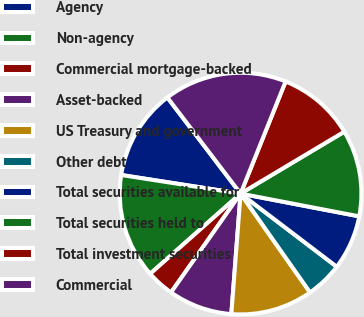<chart> <loc_0><loc_0><loc_500><loc_500><pie_chart><fcel>Agency<fcel>Non-agency<fcel>Commercial mortgage-backed<fcel>Asset-backed<fcel>US Treasury and government<fcel>Other debt<fcel>Total securities available for<fcel>Total securities held to<fcel>Total investment securities<fcel>Commercial<nl><fcel>12.18%<fcel>14.01%<fcel>3.69%<fcel>8.54%<fcel>10.97%<fcel>4.9%<fcel>7.33%<fcel>11.58%<fcel>10.36%<fcel>16.43%<nl></chart> 